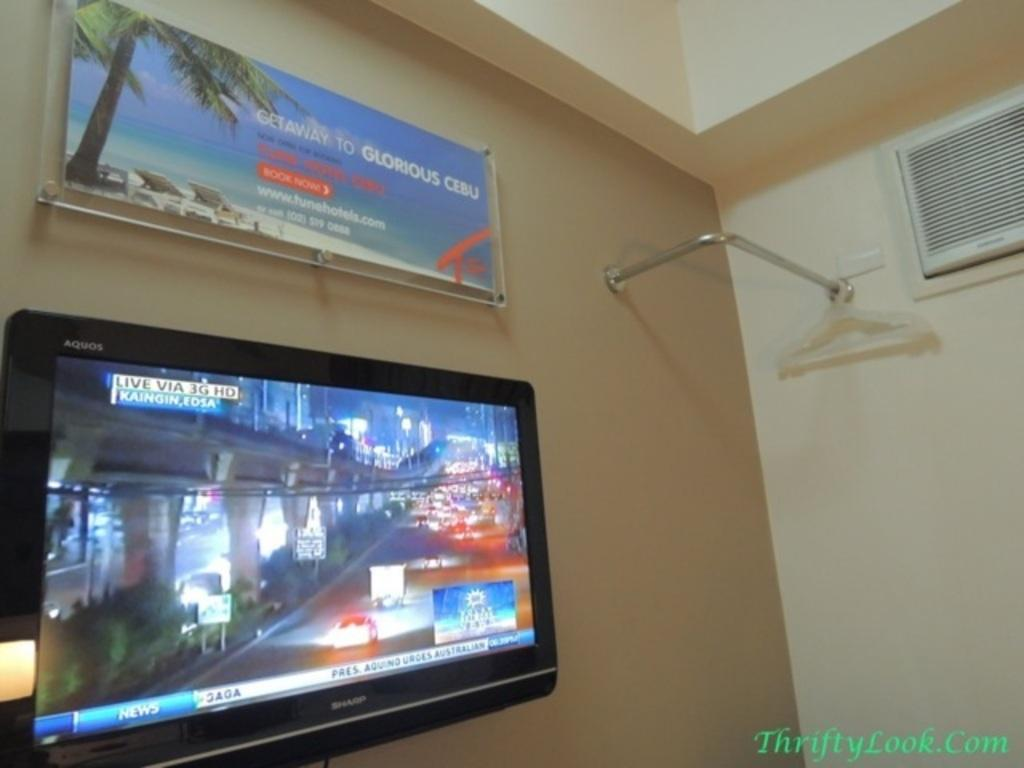<image>
Write a terse but informative summary of the picture. A wall with a TV and Travel poster that advertises a Getaway to Cebu. 